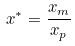<formula> <loc_0><loc_0><loc_500><loc_500>x ^ { * } = \frac { x _ { m } } { x _ { p } }</formula> 